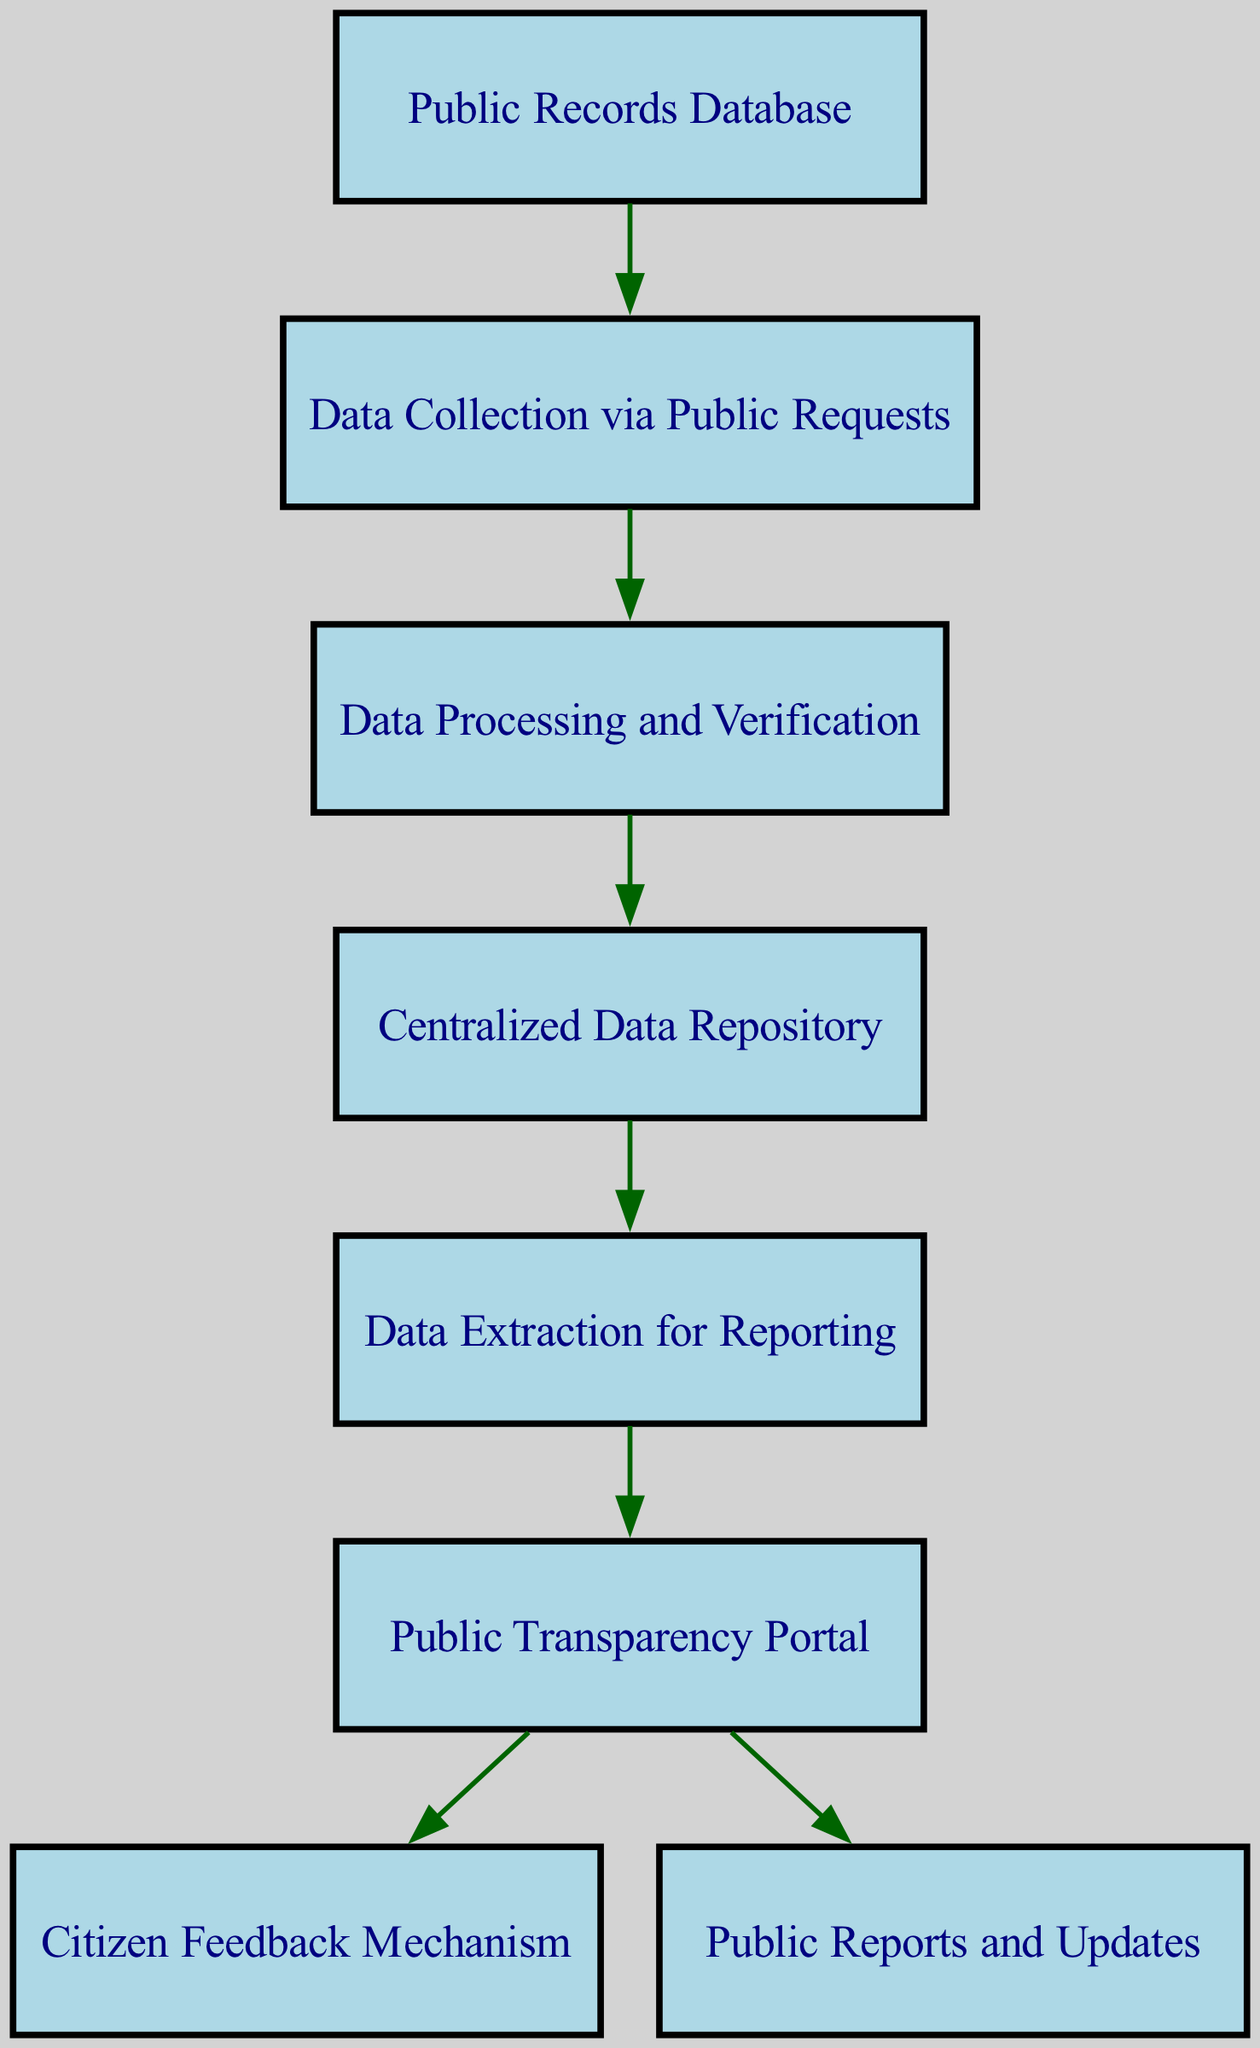What is the starting point of data in the diagram? The diagram shows that the flow of data begins at the "Public Records Database" node, which is the initial source of the data collected.
Answer: Public Records Database How many nodes are present in the diagram? By counting all unique nodes listed in the elements, there are a total of 8 nodes in the diagram.
Answer: 8 What process immediately follows data collection in the flow? After data is collected via public requests, the next step in the flow is "Data Processing and Verification," indicating that verification occurs before storage.
Answer: Data Processing and Verification Which node is responsible for extracting data for reporting? The "Data Extraction for Reporting" node is specifically designated to handle the extraction of data to be reported, as indicated by its position in the sequence.
Answer: Data Extraction for Reporting What is the output of the "Data Sharing" node? The "Data Sharing" node outputs to both the "Citizen Feedback Mechanism" and "Public Reports and Updates," indicating it facilitates engagement and transparency.
Answer: Citizen Feedback Mechanism and Public Reports and Updates How does data progress from storage to user engagement? Data progresses from the "Centralized Data Repository" to the "Data Extraction for Reporting," and then flows to the "Public Transparency Portal," where it leads to engaging with citizens.
Answer: Through Data Extraction for Reporting What type of relationship exists between "Data Storage" and "Data Extraction"? The relationship is directional, where "Data Storage" sends data to "Data Extraction," showing that data must be stored before it can be extracted for reporting.
Answer: Directional Which process involves verification of collected data? The "Data Processing and Verification" step is specified as the process where collected data is verified before being stored.
Answer: Data Processing and Verification 